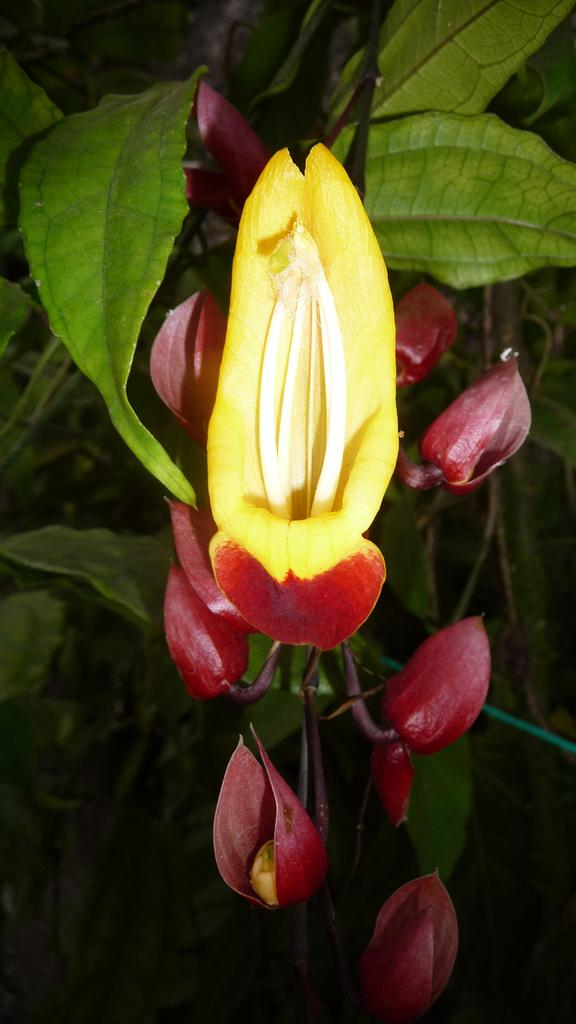What is present in the image? There is a plant in the image. What can be observed about the plant? The plant has a flower, and there are small buds around the flower. What type of bone can be seen in the image? There is no bone present in the image; it features a plant with a flower and small buds. 